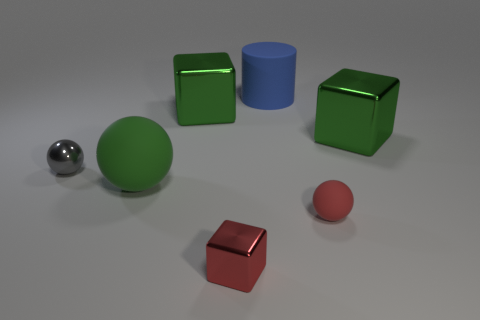Which objects have a reflective surface? The objects that show a reflective surface in the image are the small silver sphere and the two green cubes which exhibit a glossy finish, highlighting their reflective quality. 